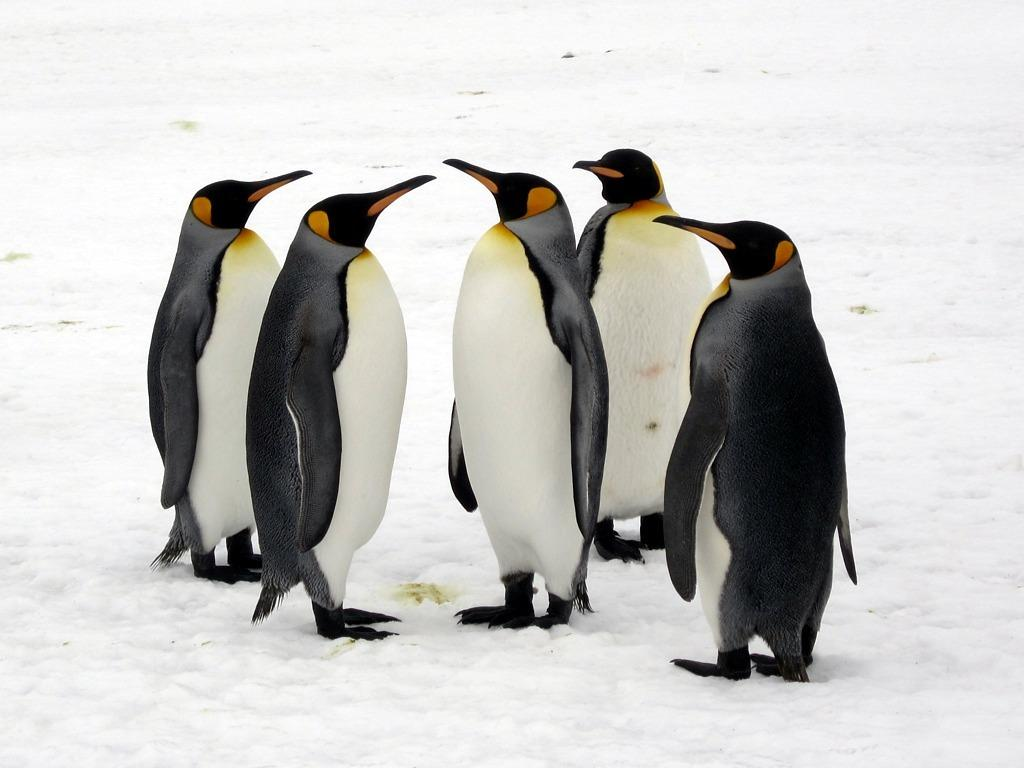How many penguins are in the image? There are 5 penguins in the image. What colors are the penguins in the image? The penguins are in black and white color. Where are the penguins located in the image? The penguins are on the snow. What type of cracker is the mother penguin feeding her baby in the image? There is no mother penguin or baby penguin present in the image, and no crackers are visible. 